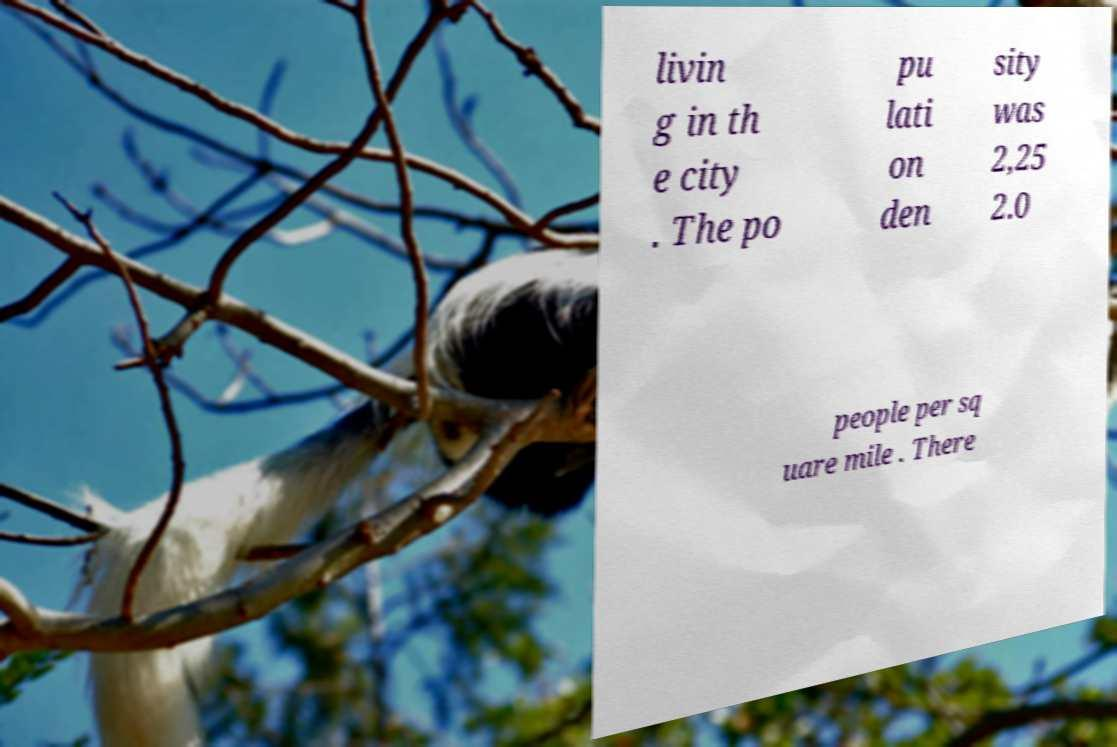Please read and relay the text visible in this image. What does it say? livin g in th e city . The po pu lati on den sity was 2,25 2.0 people per sq uare mile . There 